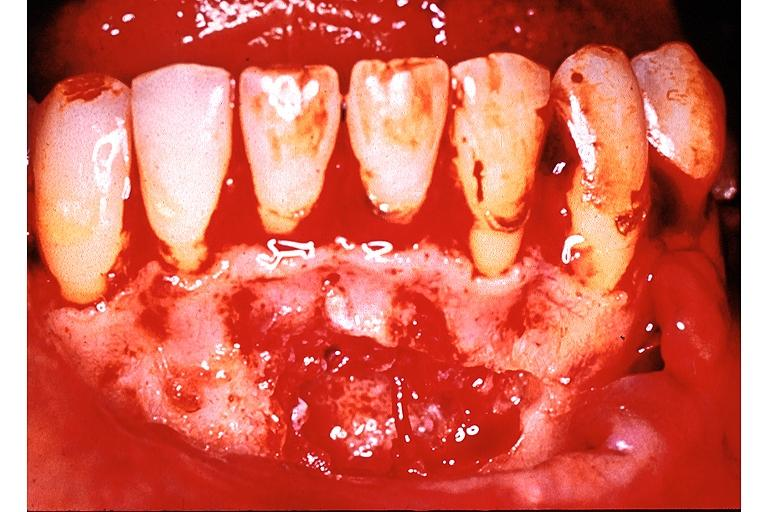s excellent example case present?
Answer the question using a single word or phrase. No 